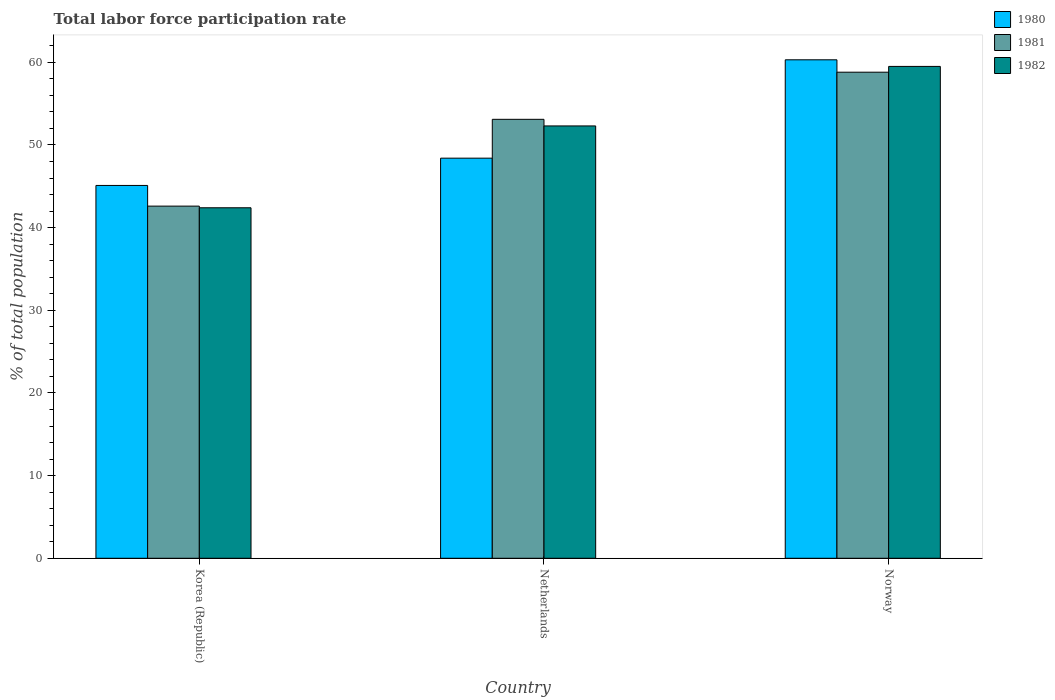How many different coloured bars are there?
Offer a very short reply. 3. Are the number of bars on each tick of the X-axis equal?
Your answer should be compact. Yes. How many bars are there on the 2nd tick from the left?
Provide a succinct answer. 3. How many bars are there on the 1st tick from the right?
Your response must be concise. 3. What is the label of the 1st group of bars from the left?
Ensure brevity in your answer.  Korea (Republic). In how many cases, is the number of bars for a given country not equal to the number of legend labels?
Provide a short and direct response. 0. What is the total labor force participation rate in 1980 in Netherlands?
Your response must be concise. 48.4. Across all countries, what is the maximum total labor force participation rate in 1982?
Your response must be concise. 59.5. Across all countries, what is the minimum total labor force participation rate in 1982?
Provide a succinct answer. 42.4. In which country was the total labor force participation rate in 1980 minimum?
Offer a terse response. Korea (Republic). What is the total total labor force participation rate in 1982 in the graph?
Your answer should be very brief. 154.2. What is the difference between the total labor force participation rate in 1982 in Netherlands and that in Norway?
Give a very brief answer. -7.2. What is the difference between the total labor force participation rate in 1980 in Korea (Republic) and the total labor force participation rate in 1982 in Norway?
Provide a short and direct response. -14.4. What is the average total labor force participation rate in 1982 per country?
Your answer should be compact. 51.4. What is the difference between the total labor force participation rate of/in 1981 and total labor force participation rate of/in 1982 in Norway?
Provide a succinct answer. -0.7. What is the ratio of the total labor force participation rate in 1982 in Korea (Republic) to that in Norway?
Your answer should be very brief. 0.71. Is the difference between the total labor force participation rate in 1981 in Korea (Republic) and Norway greater than the difference between the total labor force participation rate in 1982 in Korea (Republic) and Norway?
Make the answer very short. Yes. What is the difference between the highest and the second highest total labor force participation rate in 1982?
Provide a succinct answer. -17.1. What is the difference between the highest and the lowest total labor force participation rate in 1982?
Your response must be concise. 17.1. Is the sum of the total labor force participation rate in 1981 in Netherlands and Norway greater than the maximum total labor force participation rate in 1982 across all countries?
Offer a very short reply. Yes. What does the 2nd bar from the left in Norway represents?
Give a very brief answer. 1981. Is it the case that in every country, the sum of the total labor force participation rate in 1980 and total labor force participation rate in 1981 is greater than the total labor force participation rate in 1982?
Provide a short and direct response. Yes. How many bars are there?
Ensure brevity in your answer.  9. Are all the bars in the graph horizontal?
Your answer should be compact. No. Does the graph contain grids?
Offer a terse response. No. Where does the legend appear in the graph?
Offer a terse response. Top right. How many legend labels are there?
Your response must be concise. 3. How are the legend labels stacked?
Ensure brevity in your answer.  Vertical. What is the title of the graph?
Provide a succinct answer. Total labor force participation rate. What is the label or title of the Y-axis?
Make the answer very short. % of total population. What is the % of total population in 1980 in Korea (Republic)?
Give a very brief answer. 45.1. What is the % of total population of 1981 in Korea (Republic)?
Offer a very short reply. 42.6. What is the % of total population of 1982 in Korea (Republic)?
Your answer should be compact. 42.4. What is the % of total population of 1980 in Netherlands?
Ensure brevity in your answer.  48.4. What is the % of total population in 1981 in Netherlands?
Ensure brevity in your answer.  53.1. What is the % of total population in 1982 in Netherlands?
Ensure brevity in your answer.  52.3. What is the % of total population of 1980 in Norway?
Your answer should be very brief. 60.3. What is the % of total population in 1981 in Norway?
Provide a short and direct response. 58.8. What is the % of total population of 1982 in Norway?
Your answer should be very brief. 59.5. Across all countries, what is the maximum % of total population of 1980?
Give a very brief answer. 60.3. Across all countries, what is the maximum % of total population of 1981?
Offer a terse response. 58.8. Across all countries, what is the maximum % of total population in 1982?
Offer a terse response. 59.5. Across all countries, what is the minimum % of total population in 1980?
Offer a terse response. 45.1. Across all countries, what is the minimum % of total population in 1981?
Offer a very short reply. 42.6. Across all countries, what is the minimum % of total population of 1982?
Give a very brief answer. 42.4. What is the total % of total population in 1980 in the graph?
Give a very brief answer. 153.8. What is the total % of total population in 1981 in the graph?
Provide a succinct answer. 154.5. What is the total % of total population of 1982 in the graph?
Provide a short and direct response. 154.2. What is the difference between the % of total population of 1980 in Korea (Republic) and that in Netherlands?
Your response must be concise. -3.3. What is the difference between the % of total population of 1981 in Korea (Republic) and that in Netherlands?
Ensure brevity in your answer.  -10.5. What is the difference between the % of total population in 1982 in Korea (Republic) and that in Netherlands?
Give a very brief answer. -9.9. What is the difference between the % of total population of 1980 in Korea (Republic) and that in Norway?
Provide a short and direct response. -15.2. What is the difference between the % of total population of 1981 in Korea (Republic) and that in Norway?
Give a very brief answer. -16.2. What is the difference between the % of total population of 1982 in Korea (Republic) and that in Norway?
Give a very brief answer. -17.1. What is the difference between the % of total population of 1980 in Korea (Republic) and the % of total population of 1981 in Netherlands?
Keep it short and to the point. -8. What is the difference between the % of total population of 1980 in Korea (Republic) and the % of total population of 1982 in Netherlands?
Keep it short and to the point. -7.2. What is the difference between the % of total population in 1980 in Korea (Republic) and the % of total population in 1981 in Norway?
Provide a succinct answer. -13.7. What is the difference between the % of total population in 1980 in Korea (Republic) and the % of total population in 1982 in Norway?
Provide a succinct answer. -14.4. What is the difference between the % of total population of 1981 in Korea (Republic) and the % of total population of 1982 in Norway?
Your answer should be very brief. -16.9. What is the difference between the % of total population of 1981 in Netherlands and the % of total population of 1982 in Norway?
Make the answer very short. -6.4. What is the average % of total population of 1980 per country?
Make the answer very short. 51.27. What is the average % of total population of 1981 per country?
Offer a terse response. 51.5. What is the average % of total population in 1982 per country?
Make the answer very short. 51.4. What is the difference between the % of total population of 1980 and % of total population of 1981 in Korea (Republic)?
Your response must be concise. 2.5. What is the difference between the % of total population of 1980 and % of total population of 1982 in Korea (Republic)?
Your answer should be compact. 2.7. What is the difference between the % of total population in 1980 and % of total population in 1982 in Netherlands?
Offer a terse response. -3.9. What is the difference between the % of total population of 1980 and % of total population of 1981 in Norway?
Your answer should be very brief. 1.5. What is the difference between the % of total population of 1980 and % of total population of 1982 in Norway?
Make the answer very short. 0.8. What is the difference between the % of total population of 1981 and % of total population of 1982 in Norway?
Keep it short and to the point. -0.7. What is the ratio of the % of total population of 1980 in Korea (Republic) to that in Netherlands?
Give a very brief answer. 0.93. What is the ratio of the % of total population of 1981 in Korea (Republic) to that in Netherlands?
Offer a terse response. 0.8. What is the ratio of the % of total population in 1982 in Korea (Republic) to that in Netherlands?
Keep it short and to the point. 0.81. What is the ratio of the % of total population of 1980 in Korea (Republic) to that in Norway?
Your answer should be compact. 0.75. What is the ratio of the % of total population in 1981 in Korea (Republic) to that in Norway?
Your response must be concise. 0.72. What is the ratio of the % of total population in 1982 in Korea (Republic) to that in Norway?
Offer a very short reply. 0.71. What is the ratio of the % of total population of 1980 in Netherlands to that in Norway?
Keep it short and to the point. 0.8. What is the ratio of the % of total population in 1981 in Netherlands to that in Norway?
Provide a succinct answer. 0.9. What is the ratio of the % of total population of 1982 in Netherlands to that in Norway?
Your response must be concise. 0.88. What is the difference between the highest and the second highest % of total population of 1980?
Ensure brevity in your answer.  11.9. What is the difference between the highest and the second highest % of total population in 1981?
Your response must be concise. 5.7. What is the difference between the highest and the second highest % of total population in 1982?
Provide a short and direct response. 7.2. What is the difference between the highest and the lowest % of total population of 1980?
Ensure brevity in your answer.  15.2. What is the difference between the highest and the lowest % of total population of 1982?
Keep it short and to the point. 17.1. 